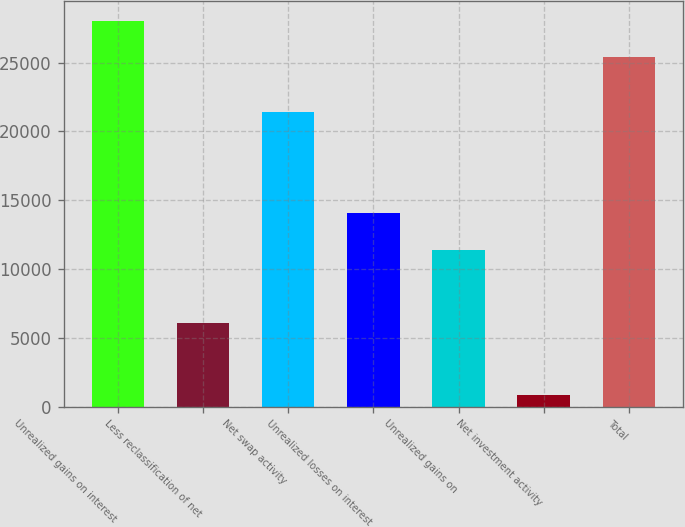<chart> <loc_0><loc_0><loc_500><loc_500><bar_chart><fcel>Unrealized gains on interest<fcel>Less reclassification of net<fcel>Net swap activity<fcel>Unrealized losses on interest<fcel>Unrealized gains on<fcel>Net investment activity<fcel>Total<nl><fcel>28049<fcel>6042<fcel>21401<fcel>14046<fcel>11378<fcel>850<fcel>25381<nl></chart> 